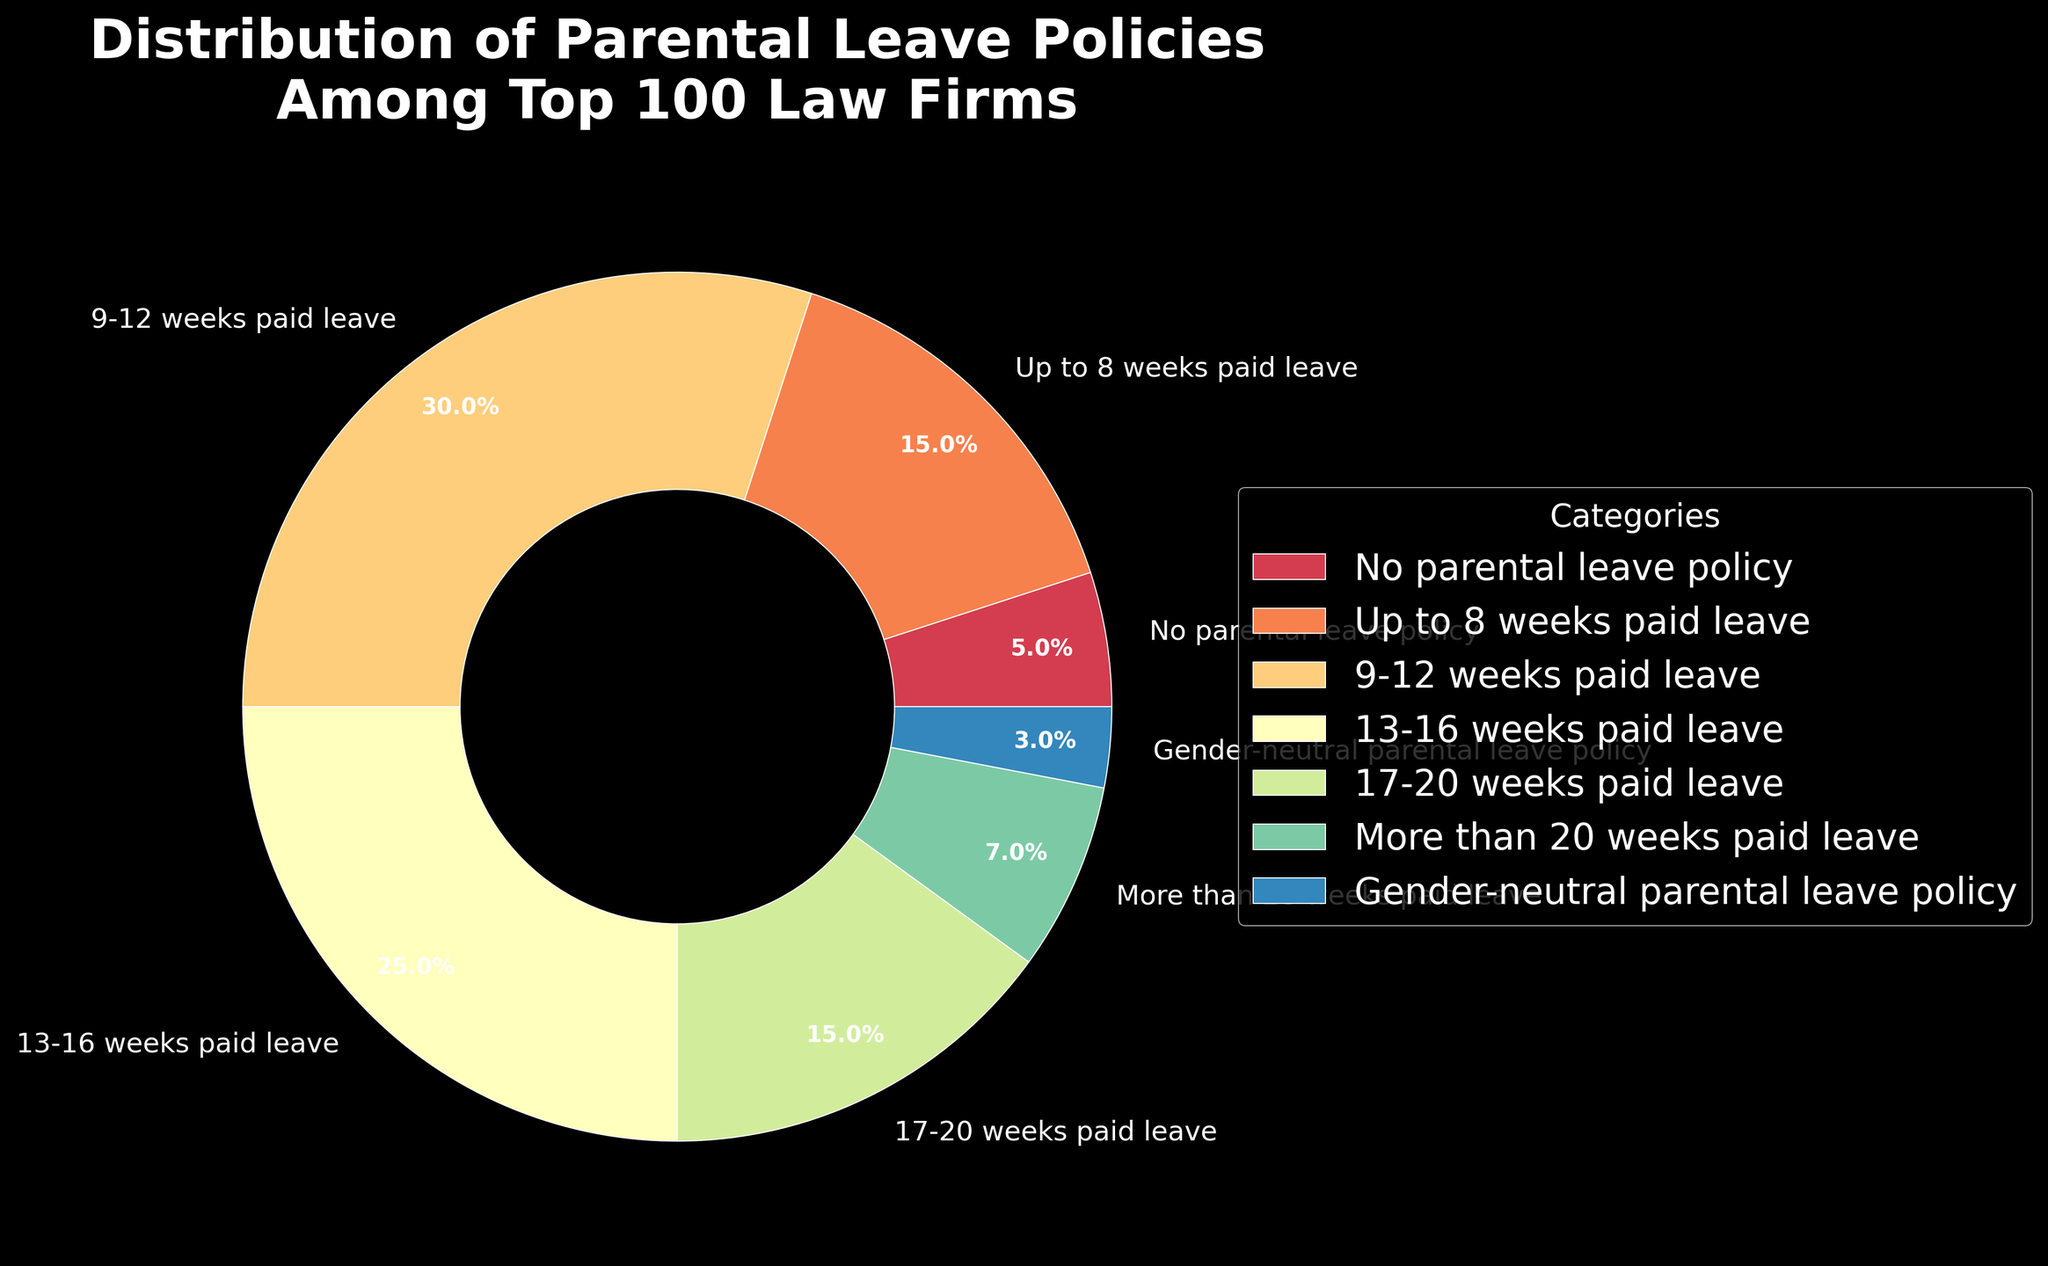What's the percentage of law firms offering more than 16 weeks of paid leave? Add the percentages of firms offering 17-20 weeks paid leave and those offering more than 20 weeks paid leave: 15% + 7% = 22%
Answer: 22% Which category has the highest percentage of law firms? Refer to the pie chart and identify the category with the largest wedge. The largest wedge corresponds to the 9-12 weeks paid leave category, which is 30%
Answer: 9-12 weeks paid leave What is the difference in percentage between law firms offering no parental leave policy and those offering more than 20 weeks paid leave? Subtract the percentage of firms offering more than 20 weeks paid leave (7%) from the percentage of firms offering no parental leave policy (5%): 5% - 7% = -2%
Answer: -2% How many categories have a higher percentage than gender-neutral parental leave policy? Count the number of categories with percentages greater than 3%. These categories are: Up to 8 weeks paid leave, 9-12 weeks paid leave, 13-16 weeks paid leave, 17-20 weeks paid leave, and More than 20 weeks paid leave. There are 5
Answer: 5 Do more law firms offer 13-16 weeks paid leave than those offering 17-20 weeks paid leave? Compare the percentages of the two categories. 13-16 weeks paid leave stands at 25%, while 17-20 weeks paid leave is 15%. Since 25% is greater than 15%, more firms offer 13-16 weeks paid leave
Answer: Yes What proportion of law firms offer up to 12 weeks of parental leave? Add the percentages of firms offering up to 8 weeks and those offering 9-12 weeks: 15% + 30% = 45%
Answer: 45% Which category is represented with the smallest wedge in the pie chart? Identify the category with the smallest wedge in the chart, which corresponds to the smallest percentage. The Gender-neutral parental leave policy category is 3%, the smallest among the categories listed
Answer: Gender-neutral parental leave What is the total percentage of law firms that offer at least some form of paid parental leave? Subtract the percentage of No parental leave policy from 100%: 100% - 5% = 95%
Answer: 95% Is the percentage of law firms with no parental leave policy higher or lower than those with gender-neutral parental leave policy? Compare the percentages of the two categories. No parental leave policy is 5%, and Gender-neutral parental leave policy is 3%. 5% is greater than 3%
Answer: Higher 